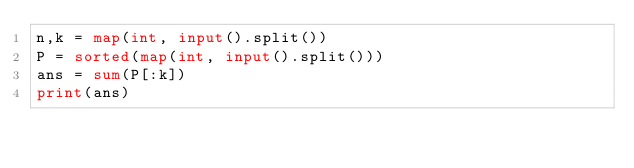<code> <loc_0><loc_0><loc_500><loc_500><_Python_>n,k = map(int, input().split())
P = sorted(map(int, input().split()))
ans = sum(P[:k])
print(ans)</code> 